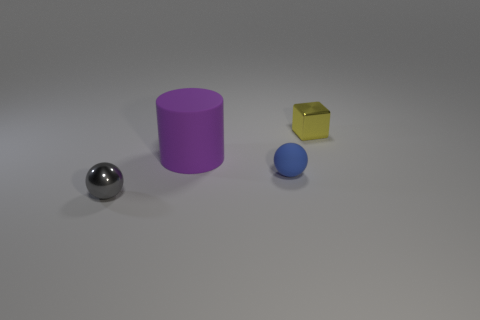Subtract all blue spheres. How many spheres are left? 1 Subtract 1 cylinders. How many cylinders are left? 0 Subtract all gray spheres. Subtract all yellow cylinders. How many spheres are left? 1 Subtract all gray spheres. How many brown cylinders are left? 0 Subtract all tiny spheres. Subtract all gray metallic balls. How many objects are left? 1 Add 1 blue balls. How many blue balls are left? 2 Add 2 big purple things. How many big purple things exist? 3 Add 1 green metallic blocks. How many objects exist? 5 Subtract 0 green balls. How many objects are left? 4 